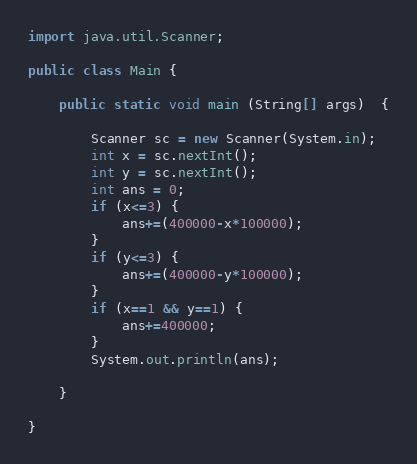<code> <loc_0><loc_0><loc_500><loc_500><_Java_>
import java.util.Scanner;

public class Main {

	public static void main (String[] args)  {

		Scanner sc = new Scanner(System.in);
		int x = sc.nextInt();
		int y = sc.nextInt();
		int ans = 0;
		if (x<=3) {
			ans+=(400000-x*100000);
		}
		if (y<=3) {
			ans+=(400000-y*100000);
		}
		if (x==1 && y==1) {
			ans+=400000;
		}
		System.out.println(ans);

	}

}
</code> 